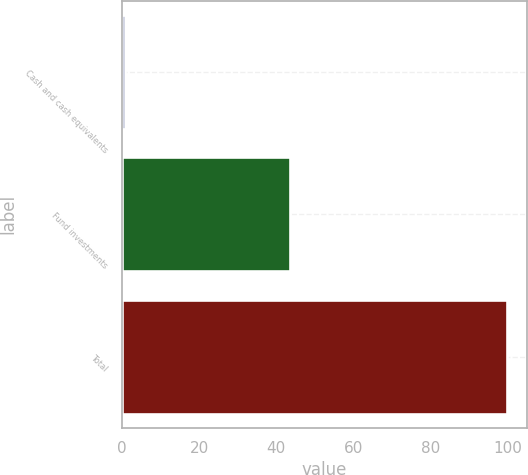Convert chart. <chart><loc_0><loc_0><loc_500><loc_500><bar_chart><fcel>Cash and cash equivalents<fcel>Fund investments<fcel>Total<nl><fcel>0.7<fcel>43.7<fcel>100<nl></chart> 